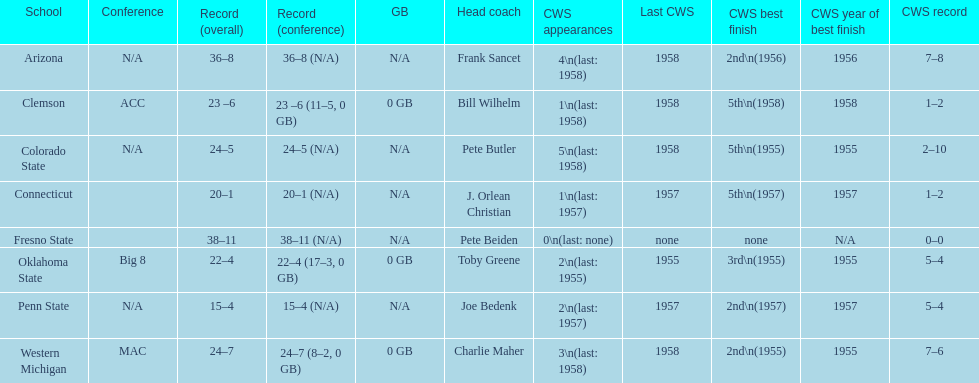List each of the schools that came in 2nd for cws best finish. Arizona, Penn State, Western Michigan. 